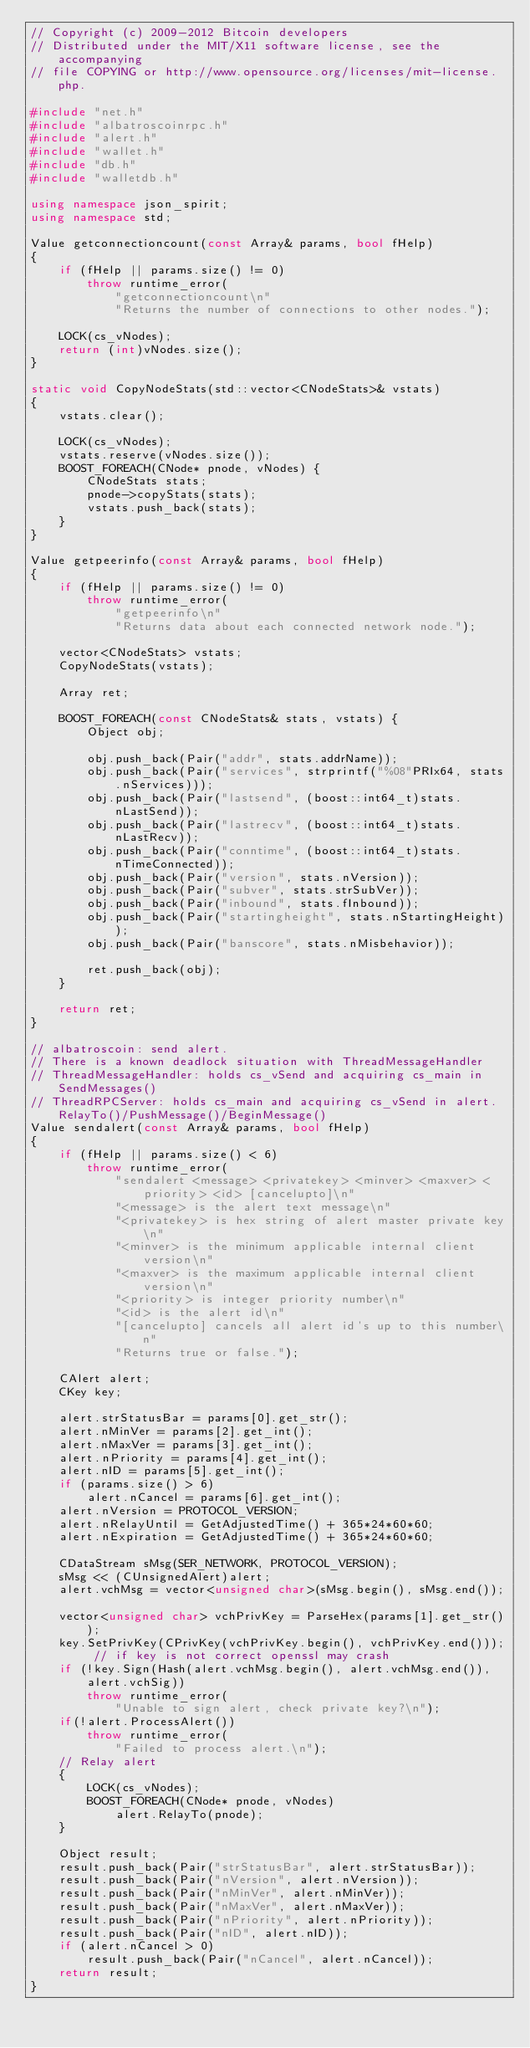Convert code to text. <code><loc_0><loc_0><loc_500><loc_500><_C++_>// Copyright (c) 2009-2012 Bitcoin developers
// Distributed under the MIT/X11 software license, see the accompanying
// file COPYING or http://www.opensource.org/licenses/mit-license.php.

#include "net.h"
#include "albatroscoinrpc.h"
#include "alert.h"
#include "wallet.h"
#include "db.h"
#include "walletdb.h"

using namespace json_spirit;
using namespace std;

Value getconnectioncount(const Array& params, bool fHelp)
{
    if (fHelp || params.size() != 0)
        throw runtime_error(
            "getconnectioncount\n"
            "Returns the number of connections to other nodes.");

    LOCK(cs_vNodes);
    return (int)vNodes.size();
}

static void CopyNodeStats(std::vector<CNodeStats>& vstats)
{
    vstats.clear();

    LOCK(cs_vNodes);
    vstats.reserve(vNodes.size());
    BOOST_FOREACH(CNode* pnode, vNodes) {
        CNodeStats stats;
        pnode->copyStats(stats);
        vstats.push_back(stats);
    }
}

Value getpeerinfo(const Array& params, bool fHelp)
{
    if (fHelp || params.size() != 0)
        throw runtime_error(
            "getpeerinfo\n"
            "Returns data about each connected network node.");

    vector<CNodeStats> vstats;
    CopyNodeStats(vstats);

    Array ret;

    BOOST_FOREACH(const CNodeStats& stats, vstats) {
        Object obj;

        obj.push_back(Pair("addr", stats.addrName));
        obj.push_back(Pair("services", strprintf("%08"PRIx64, stats.nServices)));
        obj.push_back(Pair("lastsend", (boost::int64_t)stats.nLastSend));
        obj.push_back(Pair("lastrecv", (boost::int64_t)stats.nLastRecv));
        obj.push_back(Pair("conntime", (boost::int64_t)stats.nTimeConnected));
        obj.push_back(Pair("version", stats.nVersion));
        obj.push_back(Pair("subver", stats.strSubVer));
        obj.push_back(Pair("inbound", stats.fInbound));
        obj.push_back(Pair("startingheight", stats.nStartingHeight));
        obj.push_back(Pair("banscore", stats.nMisbehavior));

        ret.push_back(obj);
    }

    return ret;
}
 
// albatroscoin: send alert.  
// There is a known deadlock situation with ThreadMessageHandler
// ThreadMessageHandler: holds cs_vSend and acquiring cs_main in SendMessages()
// ThreadRPCServer: holds cs_main and acquiring cs_vSend in alert.RelayTo()/PushMessage()/BeginMessage()
Value sendalert(const Array& params, bool fHelp)
{
    if (fHelp || params.size() < 6)
        throw runtime_error(
            "sendalert <message> <privatekey> <minver> <maxver> <priority> <id> [cancelupto]\n"
            "<message> is the alert text message\n"
            "<privatekey> is hex string of alert master private key\n"
            "<minver> is the minimum applicable internal client version\n"
            "<maxver> is the maximum applicable internal client version\n"
            "<priority> is integer priority number\n"
            "<id> is the alert id\n"
            "[cancelupto] cancels all alert id's up to this number\n"
            "Returns true or false.");

    CAlert alert;
    CKey key;

    alert.strStatusBar = params[0].get_str();
    alert.nMinVer = params[2].get_int();
    alert.nMaxVer = params[3].get_int();
    alert.nPriority = params[4].get_int();
    alert.nID = params[5].get_int();
    if (params.size() > 6)
        alert.nCancel = params[6].get_int();
    alert.nVersion = PROTOCOL_VERSION;
    alert.nRelayUntil = GetAdjustedTime() + 365*24*60*60;
    alert.nExpiration = GetAdjustedTime() + 365*24*60*60;

    CDataStream sMsg(SER_NETWORK, PROTOCOL_VERSION);
    sMsg << (CUnsignedAlert)alert;
    alert.vchMsg = vector<unsigned char>(sMsg.begin(), sMsg.end());

    vector<unsigned char> vchPrivKey = ParseHex(params[1].get_str());
    key.SetPrivKey(CPrivKey(vchPrivKey.begin(), vchPrivKey.end())); // if key is not correct openssl may crash
    if (!key.Sign(Hash(alert.vchMsg.begin(), alert.vchMsg.end()), alert.vchSig))
        throw runtime_error(
            "Unable to sign alert, check private key?\n");  
    if(!alert.ProcessAlert()) 
        throw runtime_error(
            "Failed to process alert.\n");
    // Relay alert
    {
        LOCK(cs_vNodes);
        BOOST_FOREACH(CNode* pnode, vNodes)
            alert.RelayTo(pnode);
    }

    Object result;
    result.push_back(Pair("strStatusBar", alert.strStatusBar));
    result.push_back(Pair("nVersion", alert.nVersion));
    result.push_back(Pair("nMinVer", alert.nMinVer));
    result.push_back(Pair("nMaxVer", alert.nMaxVer));
    result.push_back(Pair("nPriority", alert.nPriority));
    result.push_back(Pair("nID", alert.nID));
    if (alert.nCancel > 0)
        result.push_back(Pair("nCancel", alert.nCancel));
    return result;
}
</code> 